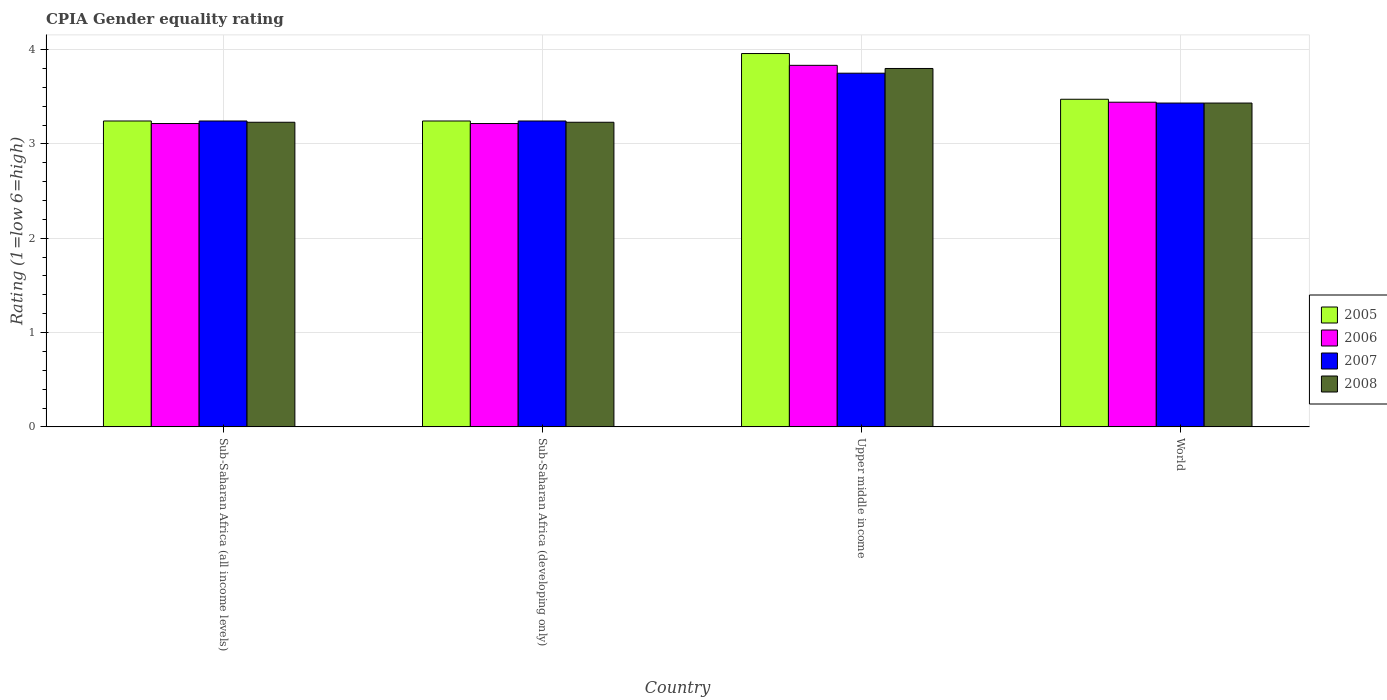Are the number of bars per tick equal to the number of legend labels?
Your answer should be very brief. Yes. How many bars are there on the 2nd tick from the right?
Your response must be concise. 4. What is the label of the 4th group of bars from the left?
Your answer should be compact. World. In how many cases, is the number of bars for a given country not equal to the number of legend labels?
Offer a terse response. 0. What is the CPIA rating in 2006 in Upper middle income?
Your answer should be very brief. 3.83. Across all countries, what is the maximum CPIA rating in 2008?
Ensure brevity in your answer.  3.8. Across all countries, what is the minimum CPIA rating in 2005?
Keep it short and to the point. 3.24. In which country was the CPIA rating in 2008 maximum?
Keep it short and to the point. Upper middle income. In which country was the CPIA rating in 2006 minimum?
Provide a short and direct response. Sub-Saharan Africa (all income levels). What is the total CPIA rating in 2007 in the graph?
Ensure brevity in your answer.  13.67. What is the difference between the CPIA rating in 2008 in Sub-Saharan Africa (all income levels) and that in Sub-Saharan Africa (developing only)?
Make the answer very short. 0. What is the difference between the CPIA rating in 2008 in Sub-Saharan Africa (all income levels) and the CPIA rating in 2007 in World?
Make the answer very short. -0.2. What is the average CPIA rating in 2006 per country?
Your answer should be very brief. 3.43. What is the difference between the CPIA rating of/in 2007 and CPIA rating of/in 2008 in Upper middle income?
Your answer should be compact. -0.05. In how many countries, is the CPIA rating in 2006 greater than 3.6?
Make the answer very short. 1. What is the ratio of the CPIA rating in 2007 in Sub-Saharan Africa (all income levels) to that in Upper middle income?
Offer a very short reply. 0.86. What is the difference between the highest and the second highest CPIA rating in 2008?
Provide a succinct answer. 0.2. What is the difference between the highest and the lowest CPIA rating in 2007?
Ensure brevity in your answer.  0.51. Is the sum of the CPIA rating in 2007 in Upper middle income and World greater than the maximum CPIA rating in 2008 across all countries?
Your answer should be very brief. Yes. Is it the case that in every country, the sum of the CPIA rating in 2005 and CPIA rating in 2006 is greater than the sum of CPIA rating in 2007 and CPIA rating in 2008?
Ensure brevity in your answer.  No. What does the 1st bar from the left in Sub-Saharan Africa (developing only) represents?
Ensure brevity in your answer.  2005. How many bars are there?
Keep it short and to the point. 16. Are all the bars in the graph horizontal?
Your response must be concise. No. How many countries are there in the graph?
Make the answer very short. 4. What is the difference between two consecutive major ticks on the Y-axis?
Provide a short and direct response. 1. Are the values on the major ticks of Y-axis written in scientific E-notation?
Provide a short and direct response. No. Does the graph contain any zero values?
Offer a terse response. No. How many legend labels are there?
Your response must be concise. 4. What is the title of the graph?
Your answer should be compact. CPIA Gender equality rating. What is the label or title of the X-axis?
Your response must be concise. Country. What is the Rating (1=low 6=high) in 2005 in Sub-Saharan Africa (all income levels)?
Your answer should be very brief. 3.24. What is the Rating (1=low 6=high) in 2006 in Sub-Saharan Africa (all income levels)?
Your answer should be compact. 3.22. What is the Rating (1=low 6=high) in 2007 in Sub-Saharan Africa (all income levels)?
Keep it short and to the point. 3.24. What is the Rating (1=low 6=high) of 2008 in Sub-Saharan Africa (all income levels)?
Your answer should be very brief. 3.23. What is the Rating (1=low 6=high) in 2005 in Sub-Saharan Africa (developing only)?
Ensure brevity in your answer.  3.24. What is the Rating (1=low 6=high) in 2006 in Sub-Saharan Africa (developing only)?
Give a very brief answer. 3.22. What is the Rating (1=low 6=high) in 2007 in Sub-Saharan Africa (developing only)?
Provide a short and direct response. 3.24. What is the Rating (1=low 6=high) of 2008 in Sub-Saharan Africa (developing only)?
Offer a very short reply. 3.23. What is the Rating (1=low 6=high) of 2005 in Upper middle income?
Provide a succinct answer. 3.96. What is the Rating (1=low 6=high) of 2006 in Upper middle income?
Your answer should be very brief. 3.83. What is the Rating (1=low 6=high) in 2007 in Upper middle income?
Offer a terse response. 3.75. What is the Rating (1=low 6=high) in 2005 in World?
Make the answer very short. 3.47. What is the Rating (1=low 6=high) of 2006 in World?
Offer a terse response. 3.44. What is the Rating (1=low 6=high) in 2007 in World?
Your response must be concise. 3.43. What is the Rating (1=low 6=high) of 2008 in World?
Keep it short and to the point. 3.43. Across all countries, what is the maximum Rating (1=low 6=high) of 2005?
Your answer should be very brief. 3.96. Across all countries, what is the maximum Rating (1=low 6=high) in 2006?
Offer a terse response. 3.83. Across all countries, what is the maximum Rating (1=low 6=high) of 2007?
Keep it short and to the point. 3.75. Across all countries, what is the maximum Rating (1=low 6=high) in 2008?
Your response must be concise. 3.8. Across all countries, what is the minimum Rating (1=low 6=high) in 2005?
Your response must be concise. 3.24. Across all countries, what is the minimum Rating (1=low 6=high) in 2006?
Give a very brief answer. 3.22. Across all countries, what is the minimum Rating (1=low 6=high) of 2007?
Offer a terse response. 3.24. Across all countries, what is the minimum Rating (1=low 6=high) in 2008?
Ensure brevity in your answer.  3.23. What is the total Rating (1=low 6=high) of 2005 in the graph?
Make the answer very short. 13.92. What is the total Rating (1=low 6=high) in 2006 in the graph?
Give a very brief answer. 13.71. What is the total Rating (1=low 6=high) in 2007 in the graph?
Offer a terse response. 13.67. What is the total Rating (1=low 6=high) of 2008 in the graph?
Your answer should be very brief. 13.69. What is the difference between the Rating (1=low 6=high) in 2006 in Sub-Saharan Africa (all income levels) and that in Sub-Saharan Africa (developing only)?
Ensure brevity in your answer.  0. What is the difference between the Rating (1=low 6=high) in 2005 in Sub-Saharan Africa (all income levels) and that in Upper middle income?
Offer a very short reply. -0.72. What is the difference between the Rating (1=low 6=high) in 2006 in Sub-Saharan Africa (all income levels) and that in Upper middle income?
Offer a terse response. -0.62. What is the difference between the Rating (1=low 6=high) in 2007 in Sub-Saharan Africa (all income levels) and that in Upper middle income?
Make the answer very short. -0.51. What is the difference between the Rating (1=low 6=high) of 2008 in Sub-Saharan Africa (all income levels) and that in Upper middle income?
Your answer should be compact. -0.57. What is the difference between the Rating (1=low 6=high) in 2005 in Sub-Saharan Africa (all income levels) and that in World?
Offer a terse response. -0.23. What is the difference between the Rating (1=low 6=high) in 2006 in Sub-Saharan Africa (all income levels) and that in World?
Your answer should be compact. -0.23. What is the difference between the Rating (1=low 6=high) in 2007 in Sub-Saharan Africa (all income levels) and that in World?
Offer a terse response. -0.19. What is the difference between the Rating (1=low 6=high) in 2008 in Sub-Saharan Africa (all income levels) and that in World?
Provide a short and direct response. -0.2. What is the difference between the Rating (1=low 6=high) in 2005 in Sub-Saharan Africa (developing only) and that in Upper middle income?
Provide a succinct answer. -0.72. What is the difference between the Rating (1=low 6=high) in 2006 in Sub-Saharan Africa (developing only) and that in Upper middle income?
Make the answer very short. -0.62. What is the difference between the Rating (1=low 6=high) in 2007 in Sub-Saharan Africa (developing only) and that in Upper middle income?
Keep it short and to the point. -0.51. What is the difference between the Rating (1=low 6=high) in 2008 in Sub-Saharan Africa (developing only) and that in Upper middle income?
Your answer should be compact. -0.57. What is the difference between the Rating (1=low 6=high) in 2005 in Sub-Saharan Africa (developing only) and that in World?
Give a very brief answer. -0.23. What is the difference between the Rating (1=low 6=high) of 2006 in Sub-Saharan Africa (developing only) and that in World?
Your answer should be compact. -0.23. What is the difference between the Rating (1=low 6=high) in 2007 in Sub-Saharan Africa (developing only) and that in World?
Your answer should be very brief. -0.19. What is the difference between the Rating (1=low 6=high) of 2008 in Sub-Saharan Africa (developing only) and that in World?
Keep it short and to the point. -0.2. What is the difference between the Rating (1=low 6=high) of 2005 in Upper middle income and that in World?
Your answer should be very brief. 0.48. What is the difference between the Rating (1=low 6=high) in 2006 in Upper middle income and that in World?
Provide a short and direct response. 0.39. What is the difference between the Rating (1=low 6=high) in 2007 in Upper middle income and that in World?
Ensure brevity in your answer.  0.32. What is the difference between the Rating (1=low 6=high) in 2008 in Upper middle income and that in World?
Provide a short and direct response. 0.37. What is the difference between the Rating (1=low 6=high) in 2005 in Sub-Saharan Africa (all income levels) and the Rating (1=low 6=high) in 2006 in Sub-Saharan Africa (developing only)?
Keep it short and to the point. 0.03. What is the difference between the Rating (1=low 6=high) of 2005 in Sub-Saharan Africa (all income levels) and the Rating (1=low 6=high) of 2008 in Sub-Saharan Africa (developing only)?
Give a very brief answer. 0.01. What is the difference between the Rating (1=low 6=high) of 2006 in Sub-Saharan Africa (all income levels) and the Rating (1=low 6=high) of 2007 in Sub-Saharan Africa (developing only)?
Keep it short and to the point. -0.03. What is the difference between the Rating (1=low 6=high) in 2006 in Sub-Saharan Africa (all income levels) and the Rating (1=low 6=high) in 2008 in Sub-Saharan Africa (developing only)?
Make the answer very short. -0.01. What is the difference between the Rating (1=low 6=high) of 2007 in Sub-Saharan Africa (all income levels) and the Rating (1=low 6=high) of 2008 in Sub-Saharan Africa (developing only)?
Keep it short and to the point. 0.01. What is the difference between the Rating (1=low 6=high) of 2005 in Sub-Saharan Africa (all income levels) and the Rating (1=low 6=high) of 2006 in Upper middle income?
Your answer should be very brief. -0.59. What is the difference between the Rating (1=low 6=high) of 2005 in Sub-Saharan Africa (all income levels) and the Rating (1=low 6=high) of 2007 in Upper middle income?
Make the answer very short. -0.51. What is the difference between the Rating (1=low 6=high) of 2005 in Sub-Saharan Africa (all income levels) and the Rating (1=low 6=high) of 2008 in Upper middle income?
Offer a very short reply. -0.56. What is the difference between the Rating (1=low 6=high) of 2006 in Sub-Saharan Africa (all income levels) and the Rating (1=low 6=high) of 2007 in Upper middle income?
Your answer should be very brief. -0.53. What is the difference between the Rating (1=low 6=high) in 2006 in Sub-Saharan Africa (all income levels) and the Rating (1=low 6=high) in 2008 in Upper middle income?
Provide a succinct answer. -0.58. What is the difference between the Rating (1=low 6=high) in 2007 in Sub-Saharan Africa (all income levels) and the Rating (1=low 6=high) in 2008 in Upper middle income?
Your answer should be very brief. -0.56. What is the difference between the Rating (1=low 6=high) in 2005 in Sub-Saharan Africa (all income levels) and the Rating (1=low 6=high) in 2006 in World?
Ensure brevity in your answer.  -0.2. What is the difference between the Rating (1=low 6=high) of 2005 in Sub-Saharan Africa (all income levels) and the Rating (1=low 6=high) of 2007 in World?
Ensure brevity in your answer.  -0.19. What is the difference between the Rating (1=low 6=high) in 2005 in Sub-Saharan Africa (all income levels) and the Rating (1=low 6=high) in 2008 in World?
Offer a terse response. -0.19. What is the difference between the Rating (1=low 6=high) in 2006 in Sub-Saharan Africa (all income levels) and the Rating (1=low 6=high) in 2007 in World?
Provide a short and direct response. -0.22. What is the difference between the Rating (1=low 6=high) in 2006 in Sub-Saharan Africa (all income levels) and the Rating (1=low 6=high) in 2008 in World?
Make the answer very short. -0.22. What is the difference between the Rating (1=low 6=high) in 2007 in Sub-Saharan Africa (all income levels) and the Rating (1=low 6=high) in 2008 in World?
Offer a terse response. -0.19. What is the difference between the Rating (1=low 6=high) of 2005 in Sub-Saharan Africa (developing only) and the Rating (1=low 6=high) of 2006 in Upper middle income?
Offer a very short reply. -0.59. What is the difference between the Rating (1=low 6=high) in 2005 in Sub-Saharan Africa (developing only) and the Rating (1=low 6=high) in 2007 in Upper middle income?
Provide a succinct answer. -0.51. What is the difference between the Rating (1=low 6=high) in 2005 in Sub-Saharan Africa (developing only) and the Rating (1=low 6=high) in 2008 in Upper middle income?
Make the answer very short. -0.56. What is the difference between the Rating (1=low 6=high) of 2006 in Sub-Saharan Africa (developing only) and the Rating (1=low 6=high) of 2007 in Upper middle income?
Provide a short and direct response. -0.53. What is the difference between the Rating (1=low 6=high) of 2006 in Sub-Saharan Africa (developing only) and the Rating (1=low 6=high) of 2008 in Upper middle income?
Make the answer very short. -0.58. What is the difference between the Rating (1=low 6=high) of 2007 in Sub-Saharan Africa (developing only) and the Rating (1=low 6=high) of 2008 in Upper middle income?
Give a very brief answer. -0.56. What is the difference between the Rating (1=low 6=high) of 2005 in Sub-Saharan Africa (developing only) and the Rating (1=low 6=high) of 2006 in World?
Ensure brevity in your answer.  -0.2. What is the difference between the Rating (1=low 6=high) in 2005 in Sub-Saharan Africa (developing only) and the Rating (1=low 6=high) in 2007 in World?
Give a very brief answer. -0.19. What is the difference between the Rating (1=low 6=high) in 2005 in Sub-Saharan Africa (developing only) and the Rating (1=low 6=high) in 2008 in World?
Offer a very short reply. -0.19. What is the difference between the Rating (1=low 6=high) of 2006 in Sub-Saharan Africa (developing only) and the Rating (1=low 6=high) of 2007 in World?
Your answer should be very brief. -0.22. What is the difference between the Rating (1=low 6=high) in 2006 in Sub-Saharan Africa (developing only) and the Rating (1=low 6=high) in 2008 in World?
Give a very brief answer. -0.22. What is the difference between the Rating (1=low 6=high) in 2007 in Sub-Saharan Africa (developing only) and the Rating (1=low 6=high) in 2008 in World?
Your answer should be very brief. -0.19. What is the difference between the Rating (1=low 6=high) of 2005 in Upper middle income and the Rating (1=low 6=high) of 2006 in World?
Make the answer very short. 0.52. What is the difference between the Rating (1=low 6=high) of 2005 in Upper middle income and the Rating (1=low 6=high) of 2007 in World?
Offer a terse response. 0.53. What is the difference between the Rating (1=low 6=high) of 2005 in Upper middle income and the Rating (1=low 6=high) of 2008 in World?
Offer a terse response. 0.53. What is the difference between the Rating (1=low 6=high) of 2006 in Upper middle income and the Rating (1=low 6=high) of 2007 in World?
Offer a very short reply. 0.4. What is the difference between the Rating (1=low 6=high) of 2006 in Upper middle income and the Rating (1=low 6=high) of 2008 in World?
Your answer should be compact. 0.4. What is the difference between the Rating (1=low 6=high) of 2007 in Upper middle income and the Rating (1=low 6=high) of 2008 in World?
Your answer should be compact. 0.32. What is the average Rating (1=low 6=high) in 2005 per country?
Your answer should be very brief. 3.48. What is the average Rating (1=low 6=high) in 2006 per country?
Provide a short and direct response. 3.43. What is the average Rating (1=low 6=high) in 2007 per country?
Ensure brevity in your answer.  3.42. What is the average Rating (1=low 6=high) in 2008 per country?
Your answer should be compact. 3.42. What is the difference between the Rating (1=low 6=high) in 2005 and Rating (1=low 6=high) in 2006 in Sub-Saharan Africa (all income levels)?
Ensure brevity in your answer.  0.03. What is the difference between the Rating (1=low 6=high) in 2005 and Rating (1=low 6=high) in 2008 in Sub-Saharan Africa (all income levels)?
Provide a succinct answer. 0.01. What is the difference between the Rating (1=low 6=high) in 2006 and Rating (1=low 6=high) in 2007 in Sub-Saharan Africa (all income levels)?
Give a very brief answer. -0.03. What is the difference between the Rating (1=low 6=high) in 2006 and Rating (1=low 6=high) in 2008 in Sub-Saharan Africa (all income levels)?
Provide a short and direct response. -0.01. What is the difference between the Rating (1=low 6=high) in 2007 and Rating (1=low 6=high) in 2008 in Sub-Saharan Africa (all income levels)?
Keep it short and to the point. 0.01. What is the difference between the Rating (1=low 6=high) in 2005 and Rating (1=low 6=high) in 2006 in Sub-Saharan Africa (developing only)?
Your answer should be very brief. 0.03. What is the difference between the Rating (1=low 6=high) in 2005 and Rating (1=low 6=high) in 2007 in Sub-Saharan Africa (developing only)?
Offer a very short reply. 0. What is the difference between the Rating (1=low 6=high) in 2005 and Rating (1=low 6=high) in 2008 in Sub-Saharan Africa (developing only)?
Give a very brief answer. 0.01. What is the difference between the Rating (1=low 6=high) in 2006 and Rating (1=low 6=high) in 2007 in Sub-Saharan Africa (developing only)?
Provide a succinct answer. -0.03. What is the difference between the Rating (1=low 6=high) in 2006 and Rating (1=low 6=high) in 2008 in Sub-Saharan Africa (developing only)?
Ensure brevity in your answer.  -0.01. What is the difference between the Rating (1=low 6=high) of 2007 and Rating (1=low 6=high) of 2008 in Sub-Saharan Africa (developing only)?
Your response must be concise. 0.01. What is the difference between the Rating (1=low 6=high) in 2005 and Rating (1=low 6=high) in 2007 in Upper middle income?
Give a very brief answer. 0.21. What is the difference between the Rating (1=low 6=high) of 2005 and Rating (1=low 6=high) of 2008 in Upper middle income?
Provide a succinct answer. 0.16. What is the difference between the Rating (1=low 6=high) of 2006 and Rating (1=low 6=high) of 2007 in Upper middle income?
Your response must be concise. 0.08. What is the difference between the Rating (1=low 6=high) in 2007 and Rating (1=low 6=high) in 2008 in Upper middle income?
Your answer should be very brief. -0.05. What is the difference between the Rating (1=low 6=high) of 2005 and Rating (1=low 6=high) of 2006 in World?
Give a very brief answer. 0.03. What is the difference between the Rating (1=low 6=high) in 2005 and Rating (1=low 6=high) in 2007 in World?
Offer a terse response. 0.04. What is the difference between the Rating (1=low 6=high) of 2005 and Rating (1=low 6=high) of 2008 in World?
Provide a succinct answer. 0.04. What is the difference between the Rating (1=low 6=high) in 2006 and Rating (1=low 6=high) in 2007 in World?
Offer a terse response. 0.01. What is the difference between the Rating (1=low 6=high) in 2006 and Rating (1=low 6=high) in 2008 in World?
Your response must be concise. 0.01. What is the difference between the Rating (1=low 6=high) in 2007 and Rating (1=low 6=high) in 2008 in World?
Provide a short and direct response. 0. What is the ratio of the Rating (1=low 6=high) of 2005 in Sub-Saharan Africa (all income levels) to that in Sub-Saharan Africa (developing only)?
Give a very brief answer. 1. What is the ratio of the Rating (1=low 6=high) of 2005 in Sub-Saharan Africa (all income levels) to that in Upper middle income?
Ensure brevity in your answer.  0.82. What is the ratio of the Rating (1=low 6=high) in 2006 in Sub-Saharan Africa (all income levels) to that in Upper middle income?
Make the answer very short. 0.84. What is the ratio of the Rating (1=low 6=high) of 2007 in Sub-Saharan Africa (all income levels) to that in Upper middle income?
Your response must be concise. 0.86. What is the ratio of the Rating (1=low 6=high) in 2008 in Sub-Saharan Africa (all income levels) to that in Upper middle income?
Ensure brevity in your answer.  0.85. What is the ratio of the Rating (1=low 6=high) in 2005 in Sub-Saharan Africa (all income levels) to that in World?
Provide a short and direct response. 0.93. What is the ratio of the Rating (1=low 6=high) in 2006 in Sub-Saharan Africa (all income levels) to that in World?
Your answer should be very brief. 0.93. What is the ratio of the Rating (1=low 6=high) of 2007 in Sub-Saharan Africa (all income levels) to that in World?
Give a very brief answer. 0.94. What is the ratio of the Rating (1=low 6=high) in 2008 in Sub-Saharan Africa (all income levels) to that in World?
Make the answer very short. 0.94. What is the ratio of the Rating (1=low 6=high) in 2005 in Sub-Saharan Africa (developing only) to that in Upper middle income?
Ensure brevity in your answer.  0.82. What is the ratio of the Rating (1=low 6=high) in 2006 in Sub-Saharan Africa (developing only) to that in Upper middle income?
Ensure brevity in your answer.  0.84. What is the ratio of the Rating (1=low 6=high) of 2007 in Sub-Saharan Africa (developing only) to that in Upper middle income?
Provide a short and direct response. 0.86. What is the ratio of the Rating (1=low 6=high) of 2008 in Sub-Saharan Africa (developing only) to that in Upper middle income?
Offer a terse response. 0.85. What is the ratio of the Rating (1=low 6=high) of 2005 in Sub-Saharan Africa (developing only) to that in World?
Provide a succinct answer. 0.93. What is the ratio of the Rating (1=low 6=high) of 2006 in Sub-Saharan Africa (developing only) to that in World?
Provide a short and direct response. 0.93. What is the ratio of the Rating (1=low 6=high) in 2007 in Sub-Saharan Africa (developing only) to that in World?
Your answer should be compact. 0.94. What is the ratio of the Rating (1=low 6=high) in 2008 in Sub-Saharan Africa (developing only) to that in World?
Ensure brevity in your answer.  0.94. What is the ratio of the Rating (1=low 6=high) in 2005 in Upper middle income to that in World?
Offer a very short reply. 1.14. What is the ratio of the Rating (1=low 6=high) of 2006 in Upper middle income to that in World?
Offer a very short reply. 1.11. What is the ratio of the Rating (1=low 6=high) of 2007 in Upper middle income to that in World?
Keep it short and to the point. 1.09. What is the ratio of the Rating (1=low 6=high) in 2008 in Upper middle income to that in World?
Your answer should be very brief. 1.11. What is the difference between the highest and the second highest Rating (1=low 6=high) in 2005?
Offer a very short reply. 0.48. What is the difference between the highest and the second highest Rating (1=low 6=high) of 2006?
Provide a short and direct response. 0.39. What is the difference between the highest and the second highest Rating (1=low 6=high) of 2007?
Provide a succinct answer. 0.32. What is the difference between the highest and the second highest Rating (1=low 6=high) of 2008?
Provide a short and direct response. 0.37. What is the difference between the highest and the lowest Rating (1=low 6=high) of 2005?
Ensure brevity in your answer.  0.72. What is the difference between the highest and the lowest Rating (1=low 6=high) in 2006?
Provide a short and direct response. 0.62. What is the difference between the highest and the lowest Rating (1=low 6=high) in 2007?
Your answer should be very brief. 0.51. What is the difference between the highest and the lowest Rating (1=low 6=high) of 2008?
Ensure brevity in your answer.  0.57. 